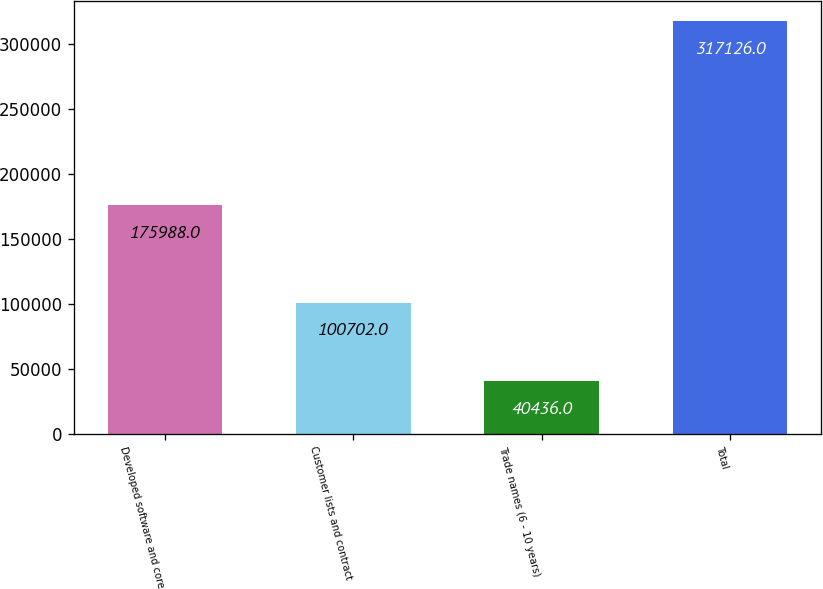<chart> <loc_0><loc_0><loc_500><loc_500><bar_chart><fcel>Developed software and core<fcel>Customer lists and contract<fcel>Trade names (6 - 10 years)<fcel>Total<nl><fcel>175988<fcel>100702<fcel>40436<fcel>317126<nl></chart> 